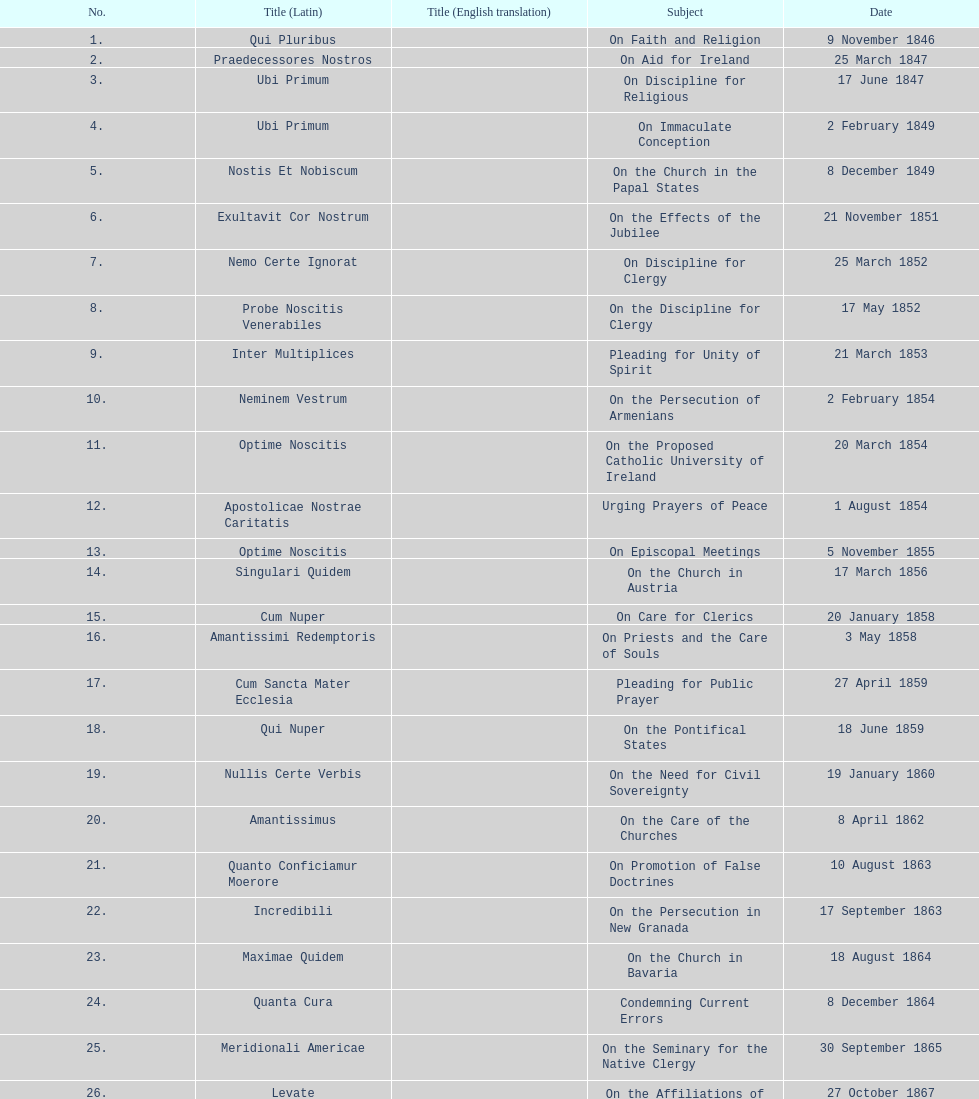Latin title of the encyclical before the encyclical with the subject "on the church in bavaria" Incredibili. 